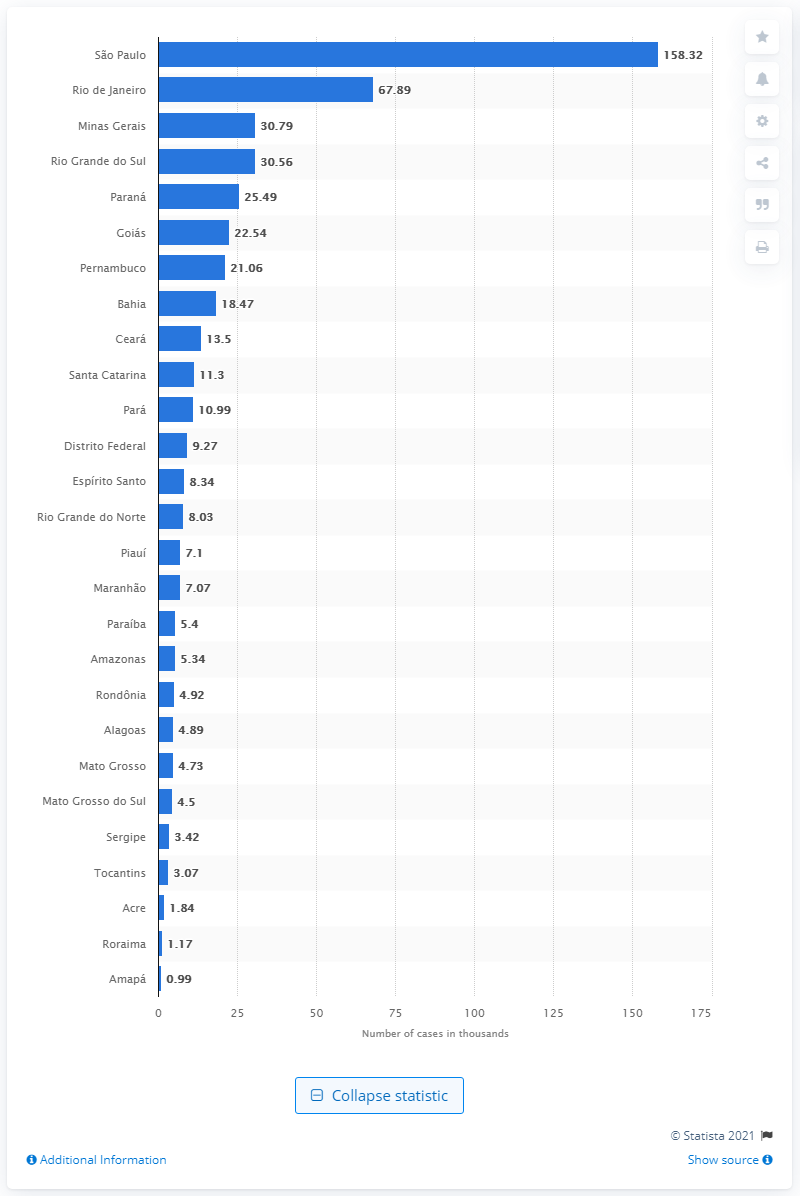Give some essential details in this illustration. In 2018, an estimated 30,800 cases of car theft and break-ins occurred in the state of Minas Gerais. Rio de Janeiro was the state with the highest number of car thefts and break-ins in Brazil in 2018. 